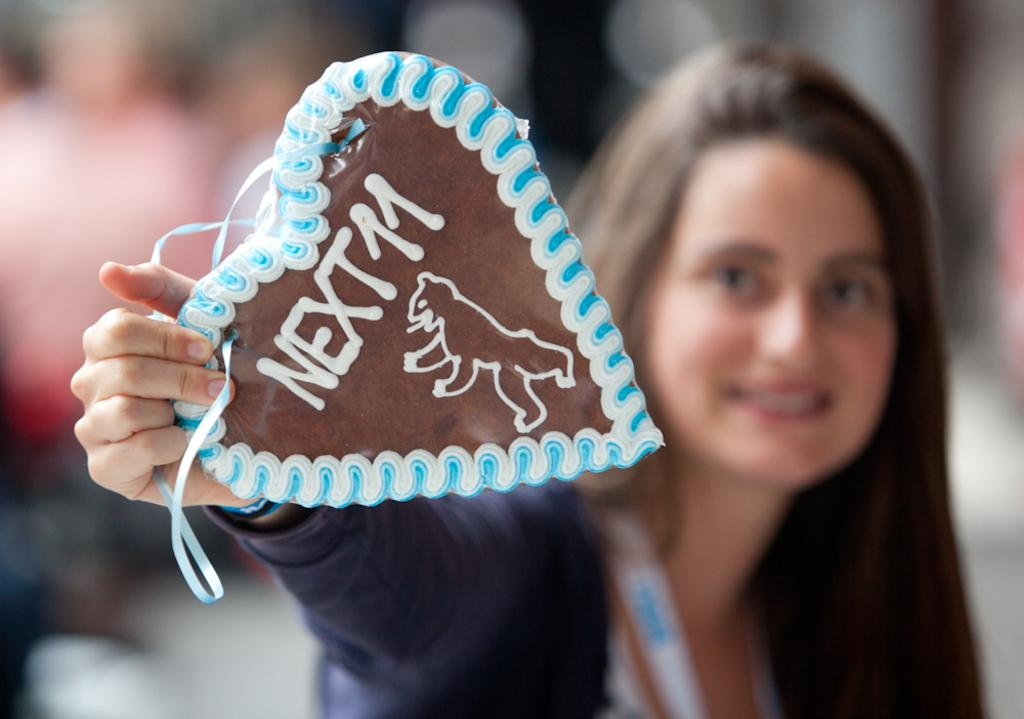What is the main subject of the image? There is a person in the image. What is the person holding in the image? The person is holding a heart-shaped object. What is the person's facial expression in the image? The person is smiling. How would you describe the background of the image? The background of the image is blurry. What type of cake can be seen in the background of the image? There is no cake present in the image; the background is blurry. 